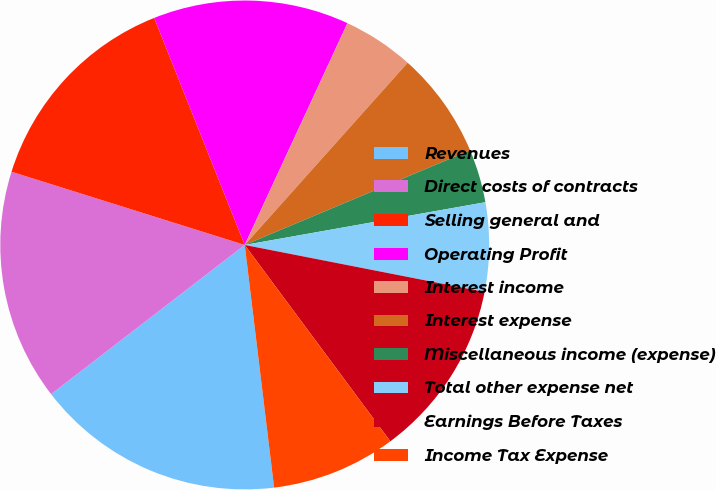Convert chart. <chart><loc_0><loc_0><loc_500><loc_500><pie_chart><fcel>Revenues<fcel>Direct costs of contracts<fcel>Selling general and<fcel>Operating Profit<fcel>Interest income<fcel>Interest expense<fcel>Miscellaneous income (expense)<fcel>Total other expense net<fcel>Earnings Before Taxes<fcel>Income Tax Expense<nl><fcel>16.47%<fcel>15.29%<fcel>14.12%<fcel>12.94%<fcel>4.71%<fcel>7.06%<fcel>3.53%<fcel>5.88%<fcel>11.76%<fcel>8.24%<nl></chart> 